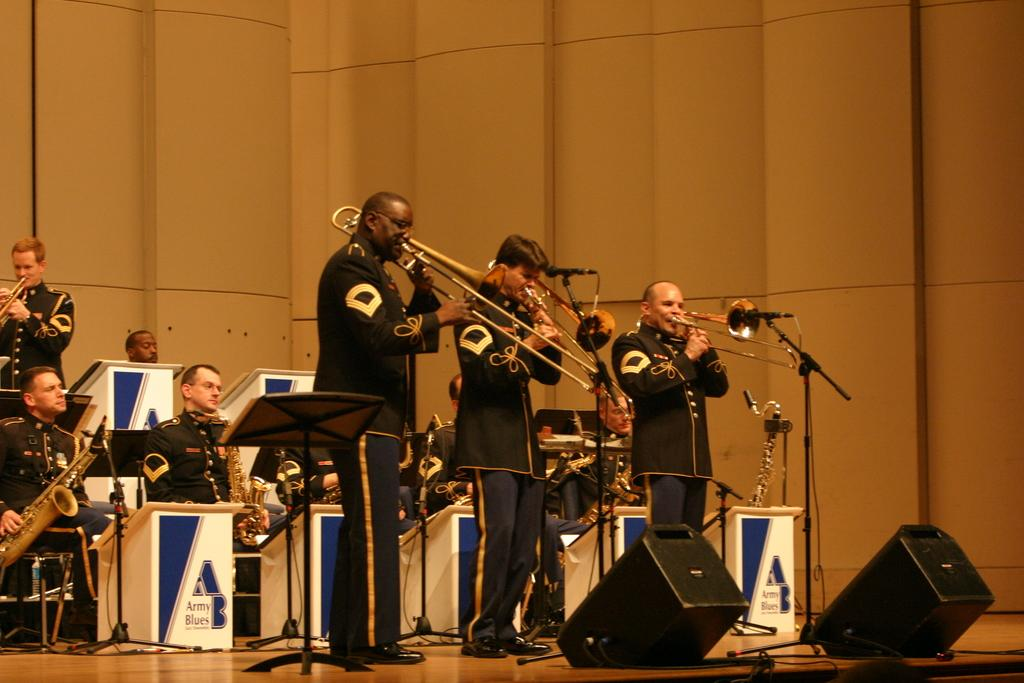What is happening in the image involving the group of people? The people in the image are holding musical instruments. Can you describe the positions of the people in the image? Some people are standing, while others are sitting on chairs. How many grapes are being held by the person playing the guitar in the image? There are no grapes present in the image, and no one is holding any grapes. 